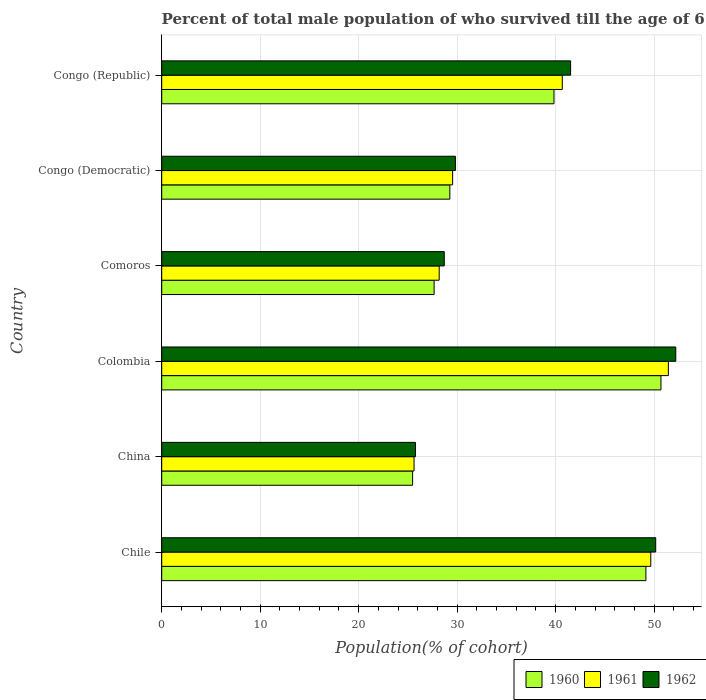How many different coloured bars are there?
Make the answer very short. 3. Are the number of bars per tick equal to the number of legend labels?
Your answer should be compact. Yes. Are the number of bars on each tick of the Y-axis equal?
Ensure brevity in your answer.  Yes. How many bars are there on the 6th tick from the top?
Your answer should be very brief. 3. What is the label of the 3rd group of bars from the top?
Your answer should be very brief. Comoros. In how many cases, is the number of bars for a given country not equal to the number of legend labels?
Offer a terse response. 0. What is the percentage of total male population who survived till the age of 65 years in 1962 in Chile?
Keep it short and to the point. 50.16. Across all countries, what is the maximum percentage of total male population who survived till the age of 65 years in 1962?
Provide a short and direct response. 52.2. Across all countries, what is the minimum percentage of total male population who survived till the age of 65 years in 1960?
Keep it short and to the point. 25.48. In which country was the percentage of total male population who survived till the age of 65 years in 1960 minimum?
Provide a succinct answer. China. What is the total percentage of total male population who survived till the age of 65 years in 1961 in the graph?
Your response must be concise. 225.14. What is the difference between the percentage of total male population who survived till the age of 65 years in 1962 in Colombia and that in Comoros?
Offer a terse response. 23.51. What is the difference between the percentage of total male population who survived till the age of 65 years in 1960 in Chile and the percentage of total male population who survived till the age of 65 years in 1961 in Congo (Democratic)?
Your answer should be compact. 19.63. What is the average percentage of total male population who survived till the age of 65 years in 1961 per country?
Your answer should be compact. 37.52. What is the difference between the percentage of total male population who survived till the age of 65 years in 1962 and percentage of total male population who survived till the age of 65 years in 1960 in Congo (Democratic)?
Ensure brevity in your answer.  0.57. What is the ratio of the percentage of total male population who survived till the age of 65 years in 1962 in Comoros to that in Congo (Democratic)?
Your answer should be very brief. 0.96. Is the percentage of total male population who survived till the age of 65 years in 1960 in Chile less than that in Comoros?
Provide a succinct answer. No. Is the difference between the percentage of total male population who survived till the age of 65 years in 1962 in Chile and Comoros greater than the difference between the percentage of total male population who survived till the age of 65 years in 1960 in Chile and Comoros?
Your answer should be compact. No. What is the difference between the highest and the second highest percentage of total male population who survived till the age of 65 years in 1960?
Provide a short and direct response. 1.53. What is the difference between the highest and the lowest percentage of total male population who survived till the age of 65 years in 1962?
Provide a succinct answer. 26.44. Is the sum of the percentage of total male population who survived till the age of 65 years in 1962 in Congo (Democratic) and Congo (Republic) greater than the maximum percentage of total male population who survived till the age of 65 years in 1961 across all countries?
Make the answer very short. Yes. What does the 1st bar from the top in Comoros represents?
Offer a terse response. 1962. What does the 2nd bar from the bottom in Chile represents?
Give a very brief answer. 1961. Are all the bars in the graph horizontal?
Your response must be concise. Yes. What is the difference between two consecutive major ticks on the X-axis?
Make the answer very short. 10. Are the values on the major ticks of X-axis written in scientific E-notation?
Your answer should be very brief. No. Does the graph contain any zero values?
Your answer should be compact. No. Does the graph contain grids?
Offer a very short reply. Yes. What is the title of the graph?
Your answer should be compact. Percent of total male population of who survived till the age of 65 years. What is the label or title of the X-axis?
Your answer should be compact. Population(% of cohort). What is the Population(% of cohort) in 1960 in Chile?
Ensure brevity in your answer.  49.17. What is the Population(% of cohort) of 1961 in Chile?
Make the answer very short. 49.67. What is the Population(% of cohort) in 1962 in Chile?
Provide a short and direct response. 50.16. What is the Population(% of cohort) of 1960 in China?
Offer a very short reply. 25.48. What is the Population(% of cohort) in 1961 in China?
Your answer should be compact. 25.62. What is the Population(% of cohort) in 1962 in China?
Your answer should be compact. 25.77. What is the Population(% of cohort) in 1960 in Colombia?
Provide a short and direct response. 50.7. What is the Population(% of cohort) of 1961 in Colombia?
Offer a terse response. 51.45. What is the Population(% of cohort) in 1962 in Colombia?
Provide a short and direct response. 52.2. What is the Population(% of cohort) of 1960 in Comoros?
Give a very brief answer. 27.66. What is the Population(% of cohort) of 1961 in Comoros?
Ensure brevity in your answer.  28.18. What is the Population(% of cohort) of 1962 in Comoros?
Your answer should be compact. 28.69. What is the Population(% of cohort) of 1960 in Congo (Democratic)?
Make the answer very short. 29.26. What is the Population(% of cohort) of 1961 in Congo (Democratic)?
Provide a succinct answer. 29.54. What is the Population(% of cohort) of 1962 in Congo (Democratic)?
Make the answer very short. 29.82. What is the Population(% of cohort) in 1960 in Congo (Republic)?
Make the answer very short. 39.84. What is the Population(% of cohort) of 1961 in Congo (Republic)?
Offer a terse response. 40.68. What is the Population(% of cohort) in 1962 in Congo (Republic)?
Keep it short and to the point. 41.52. Across all countries, what is the maximum Population(% of cohort) in 1960?
Your answer should be very brief. 50.7. Across all countries, what is the maximum Population(% of cohort) in 1961?
Your answer should be compact. 51.45. Across all countries, what is the maximum Population(% of cohort) in 1962?
Offer a terse response. 52.2. Across all countries, what is the minimum Population(% of cohort) in 1960?
Offer a very short reply. 25.48. Across all countries, what is the minimum Population(% of cohort) of 1961?
Offer a terse response. 25.62. Across all countries, what is the minimum Population(% of cohort) in 1962?
Offer a terse response. 25.77. What is the total Population(% of cohort) of 1960 in the graph?
Ensure brevity in your answer.  222.1. What is the total Population(% of cohort) of 1961 in the graph?
Your answer should be very brief. 225.14. What is the total Population(% of cohort) of 1962 in the graph?
Your response must be concise. 228.18. What is the difference between the Population(% of cohort) in 1960 in Chile and that in China?
Give a very brief answer. 23.69. What is the difference between the Population(% of cohort) of 1961 in Chile and that in China?
Your answer should be very brief. 24.04. What is the difference between the Population(% of cohort) of 1962 in Chile and that in China?
Ensure brevity in your answer.  24.4. What is the difference between the Population(% of cohort) in 1960 in Chile and that in Colombia?
Keep it short and to the point. -1.53. What is the difference between the Population(% of cohort) of 1961 in Chile and that in Colombia?
Your response must be concise. -1.78. What is the difference between the Population(% of cohort) in 1962 in Chile and that in Colombia?
Offer a terse response. -2.04. What is the difference between the Population(% of cohort) in 1960 in Chile and that in Comoros?
Your answer should be compact. 21.51. What is the difference between the Population(% of cohort) in 1961 in Chile and that in Comoros?
Your answer should be very brief. 21.49. What is the difference between the Population(% of cohort) in 1962 in Chile and that in Comoros?
Offer a terse response. 21.47. What is the difference between the Population(% of cohort) of 1960 in Chile and that in Congo (Democratic)?
Your response must be concise. 19.91. What is the difference between the Population(% of cohort) of 1961 in Chile and that in Congo (Democratic)?
Give a very brief answer. 20.12. What is the difference between the Population(% of cohort) in 1962 in Chile and that in Congo (Democratic)?
Your response must be concise. 20.34. What is the difference between the Population(% of cohort) in 1960 in Chile and that in Congo (Republic)?
Your response must be concise. 9.33. What is the difference between the Population(% of cohort) of 1961 in Chile and that in Congo (Republic)?
Your response must be concise. 8.99. What is the difference between the Population(% of cohort) in 1962 in Chile and that in Congo (Republic)?
Ensure brevity in your answer.  8.64. What is the difference between the Population(% of cohort) of 1960 in China and that in Colombia?
Provide a short and direct response. -25.22. What is the difference between the Population(% of cohort) in 1961 in China and that in Colombia?
Provide a succinct answer. -25.83. What is the difference between the Population(% of cohort) of 1962 in China and that in Colombia?
Keep it short and to the point. -26.44. What is the difference between the Population(% of cohort) of 1960 in China and that in Comoros?
Provide a short and direct response. -2.18. What is the difference between the Population(% of cohort) in 1961 in China and that in Comoros?
Offer a terse response. -2.55. What is the difference between the Population(% of cohort) in 1962 in China and that in Comoros?
Offer a very short reply. -2.93. What is the difference between the Population(% of cohort) in 1960 in China and that in Congo (Democratic)?
Ensure brevity in your answer.  -3.78. What is the difference between the Population(% of cohort) in 1961 in China and that in Congo (Democratic)?
Offer a terse response. -3.92. What is the difference between the Population(% of cohort) in 1962 in China and that in Congo (Democratic)?
Offer a very short reply. -4.06. What is the difference between the Population(% of cohort) of 1960 in China and that in Congo (Republic)?
Provide a succinct answer. -14.36. What is the difference between the Population(% of cohort) of 1961 in China and that in Congo (Republic)?
Give a very brief answer. -15.05. What is the difference between the Population(% of cohort) of 1962 in China and that in Congo (Republic)?
Provide a succinct answer. -15.75. What is the difference between the Population(% of cohort) in 1960 in Colombia and that in Comoros?
Provide a short and direct response. 23.03. What is the difference between the Population(% of cohort) of 1961 in Colombia and that in Comoros?
Your answer should be compact. 23.27. What is the difference between the Population(% of cohort) of 1962 in Colombia and that in Comoros?
Offer a very short reply. 23.51. What is the difference between the Population(% of cohort) in 1960 in Colombia and that in Congo (Democratic)?
Your answer should be compact. 21.44. What is the difference between the Population(% of cohort) of 1961 in Colombia and that in Congo (Democratic)?
Offer a very short reply. 21.91. What is the difference between the Population(% of cohort) in 1962 in Colombia and that in Congo (Democratic)?
Provide a succinct answer. 22.38. What is the difference between the Population(% of cohort) of 1960 in Colombia and that in Congo (Republic)?
Your response must be concise. 10.86. What is the difference between the Population(% of cohort) in 1961 in Colombia and that in Congo (Republic)?
Make the answer very short. 10.77. What is the difference between the Population(% of cohort) of 1962 in Colombia and that in Congo (Republic)?
Offer a terse response. 10.68. What is the difference between the Population(% of cohort) in 1960 in Comoros and that in Congo (Democratic)?
Provide a short and direct response. -1.6. What is the difference between the Population(% of cohort) of 1961 in Comoros and that in Congo (Democratic)?
Your answer should be very brief. -1.36. What is the difference between the Population(% of cohort) of 1962 in Comoros and that in Congo (Democratic)?
Your answer should be compact. -1.13. What is the difference between the Population(% of cohort) of 1960 in Comoros and that in Congo (Republic)?
Provide a succinct answer. -12.17. What is the difference between the Population(% of cohort) in 1961 in Comoros and that in Congo (Republic)?
Offer a very short reply. -12.5. What is the difference between the Population(% of cohort) of 1962 in Comoros and that in Congo (Republic)?
Your answer should be very brief. -12.83. What is the difference between the Population(% of cohort) in 1960 in Congo (Democratic) and that in Congo (Republic)?
Your answer should be very brief. -10.58. What is the difference between the Population(% of cohort) in 1961 in Congo (Democratic) and that in Congo (Republic)?
Ensure brevity in your answer.  -11.14. What is the difference between the Population(% of cohort) in 1962 in Congo (Democratic) and that in Congo (Republic)?
Ensure brevity in your answer.  -11.7. What is the difference between the Population(% of cohort) of 1960 in Chile and the Population(% of cohort) of 1961 in China?
Give a very brief answer. 23.55. What is the difference between the Population(% of cohort) in 1960 in Chile and the Population(% of cohort) in 1962 in China?
Offer a terse response. 23.4. What is the difference between the Population(% of cohort) in 1961 in Chile and the Population(% of cohort) in 1962 in China?
Provide a succinct answer. 23.9. What is the difference between the Population(% of cohort) in 1960 in Chile and the Population(% of cohort) in 1961 in Colombia?
Your answer should be very brief. -2.28. What is the difference between the Population(% of cohort) in 1960 in Chile and the Population(% of cohort) in 1962 in Colombia?
Offer a very short reply. -3.03. What is the difference between the Population(% of cohort) of 1961 in Chile and the Population(% of cohort) of 1962 in Colombia?
Offer a very short reply. -2.54. What is the difference between the Population(% of cohort) of 1960 in Chile and the Population(% of cohort) of 1961 in Comoros?
Your answer should be compact. 20.99. What is the difference between the Population(% of cohort) in 1960 in Chile and the Population(% of cohort) in 1962 in Comoros?
Give a very brief answer. 20.48. What is the difference between the Population(% of cohort) of 1961 in Chile and the Population(% of cohort) of 1962 in Comoros?
Provide a short and direct response. 20.97. What is the difference between the Population(% of cohort) of 1960 in Chile and the Population(% of cohort) of 1961 in Congo (Democratic)?
Your answer should be compact. 19.63. What is the difference between the Population(% of cohort) in 1960 in Chile and the Population(% of cohort) in 1962 in Congo (Democratic)?
Provide a succinct answer. 19.34. What is the difference between the Population(% of cohort) of 1961 in Chile and the Population(% of cohort) of 1962 in Congo (Democratic)?
Provide a succinct answer. 19.84. What is the difference between the Population(% of cohort) in 1960 in Chile and the Population(% of cohort) in 1961 in Congo (Republic)?
Ensure brevity in your answer.  8.49. What is the difference between the Population(% of cohort) in 1960 in Chile and the Population(% of cohort) in 1962 in Congo (Republic)?
Keep it short and to the point. 7.65. What is the difference between the Population(% of cohort) of 1961 in Chile and the Population(% of cohort) of 1962 in Congo (Republic)?
Make the answer very short. 8.15. What is the difference between the Population(% of cohort) of 1960 in China and the Population(% of cohort) of 1961 in Colombia?
Give a very brief answer. -25.97. What is the difference between the Population(% of cohort) of 1960 in China and the Population(% of cohort) of 1962 in Colombia?
Ensure brevity in your answer.  -26.72. What is the difference between the Population(% of cohort) of 1961 in China and the Population(% of cohort) of 1962 in Colombia?
Keep it short and to the point. -26.58. What is the difference between the Population(% of cohort) of 1960 in China and the Population(% of cohort) of 1961 in Comoros?
Provide a succinct answer. -2.7. What is the difference between the Population(% of cohort) in 1960 in China and the Population(% of cohort) in 1962 in Comoros?
Your answer should be very brief. -3.21. What is the difference between the Population(% of cohort) in 1961 in China and the Population(% of cohort) in 1962 in Comoros?
Give a very brief answer. -3.07. What is the difference between the Population(% of cohort) of 1960 in China and the Population(% of cohort) of 1961 in Congo (Democratic)?
Give a very brief answer. -4.06. What is the difference between the Population(% of cohort) of 1960 in China and the Population(% of cohort) of 1962 in Congo (Democratic)?
Keep it short and to the point. -4.35. What is the difference between the Population(% of cohort) in 1961 in China and the Population(% of cohort) in 1962 in Congo (Democratic)?
Your answer should be very brief. -4.2. What is the difference between the Population(% of cohort) of 1960 in China and the Population(% of cohort) of 1961 in Congo (Republic)?
Give a very brief answer. -15.2. What is the difference between the Population(% of cohort) in 1960 in China and the Population(% of cohort) in 1962 in Congo (Republic)?
Provide a succinct answer. -16.04. What is the difference between the Population(% of cohort) of 1961 in China and the Population(% of cohort) of 1962 in Congo (Republic)?
Offer a terse response. -15.9. What is the difference between the Population(% of cohort) in 1960 in Colombia and the Population(% of cohort) in 1961 in Comoros?
Make the answer very short. 22.52. What is the difference between the Population(% of cohort) in 1960 in Colombia and the Population(% of cohort) in 1962 in Comoros?
Ensure brevity in your answer.  22. What is the difference between the Population(% of cohort) of 1961 in Colombia and the Population(% of cohort) of 1962 in Comoros?
Your answer should be very brief. 22.76. What is the difference between the Population(% of cohort) of 1960 in Colombia and the Population(% of cohort) of 1961 in Congo (Democratic)?
Ensure brevity in your answer.  21.16. What is the difference between the Population(% of cohort) in 1960 in Colombia and the Population(% of cohort) in 1962 in Congo (Democratic)?
Provide a succinct answer. 20.87. What is the difference between the Population(% of cohort) in 1961 in Colombia and the Population(% of cohort) in 1962 in Congo (Democratic)?
Keep it short and to the point. 21.63. What is the difference between the Population(% of cohort) in 1960 in Colombia and the Population(% of cohort) in 1961 in Congo (Republic)?
Make the answer very short. 10.02. What is the difference between the Population(% of cohort) in 1960 in Colombia and the Population(% of cohort) in 1962 in Congo (Republic)?
Your answer should be compact. 9.18. What is the difference between the Population(% of cohort) in 1961 in Colombia and the Population(% of cohort) in 1962 in Congo (Republic)?
Your response must be concise. 9.93. What is the difference between the Population(% of cohort) in 1960 in Comoros and the Population(% of cohort) in 1961 in Congo (Democratic)?
Offer a very short reply. -1.88. What is the difference between the Population(% of cohort) in 1960 in Comoros and the Population(% of cohort) in 1962 in Congo (Democratic)?
Your answer should be very brief. -2.16. What is the difference between the Population(% of cohort) of 1961 in Comoros and the Population(% of cohort) of 1962 in Congo (Democratic)?
Your response must be concise. -1.65. What is the difference between the Population(% of cohort) of 1960 in Comoros and the Population(% of cohort) of 1961 in Congo (Republic)?
Provide a succinct answer. -13.02. What is the difference between the Population(% of cohort) in 1960 in Comoros and the Population(% of cohort) in 1962 in Congo (Republic)?
Give a very brief answer. -13.86. What is the difference between the Population(% of cohort) of 1961 in Comoros and the Population(% of cohort) of 1962 in Congo (Republic)?
Give a very brief answer. -13.34. What is the difference between the Population(% of cohort) of 1960 in Congo (Democratic) and the Population(% of cohort) of 1961 in Congo (Republic)?
Offer a terse response. -11.42. What is the difference between the Population(% of cohort) in 1960 in Congo (Democratic) and the Population(% of cohort) in 1962 in Congo (Republic)?
Keep it short and to the point. -12.26. What is the difference between the Population(% of cohort) of 1961 in Congo (Democratic) and the Population(% of cohort) of 1962 in Congo (Republic)?
Your response must be concise. -11.98. What is the average Population(% of cohort) in 1960 per country?
Give a very brief answer. 37.02. What is the average Population(% of cohort) of 1961 per country?
Your response must be concise. 37.52. What is the average Population(% of cohort) in 1962 per country?
Your answer should be very brief. 38.03. What is the difference between the Population(% of cohort) in 1960 and Population(% of cohort) in 1961 in Chile?
Your response must be concise. -0.5. What is the difference between the Population(% of cohort) in 1960 and Population(% of cohort) in 1962 in Chile?
Provide a short and direct response. -1. What is the difference between the Population(% of cohort) in 1961 and Population(% of cohort) in 1962 in Chile?
Offer a terse response. -0.5. What is the difference between the Population(% of cohort) of 1960 and Population(% of cohort) of 1961 in China?
Keep it short and to the point. -0.14. What is the difference between the Population(% of cohort) of 1960 and Population(% of cohort) of 1962 in China?
Your answer should be very brief. -0.29. What is the difference between the Population(% of cohort) of 1961 and Population(% of cohort) of 1962 in China?
Provide a succinct answer. -0.14. What is the difference between the Population(% of cohort) in 1960 and Population(% of cohort) in 1961 in Colombia?
Offer a very short reply. -0.75. What is the difference between the Population(% of cohort) of 1960 and Population(% of cohort) of 1962 in Colombia?
Offer a terse response. -1.51. What is the difference between the Population(% of cohort) of 1961 and Population(% of cohort) of 1962 in Colombia?
Provide a succinct answer. -0.75. What is the difference between the Population(% of cohort) in 1960 and Population(% of cohort) in 1961 in Comoros?
Your response must be concise. -0.52. What is the difference between the Population(% of cohort) in 1960 and Population(% of cohort) in 1962 in Comoros?
Your answer should be compact. -1.03. What is the difference between the Population(% of cohort) of 1961 and Population(% of cohort) of 1962 in Comoros?
Your response must be concise. -0.52. What is the difference between the Population(% of cohort) in 1960 and Population(% of cohort) in 1961 in Congo (Democratic)?
Keep it short and to the point. -0.28. What is the difference between the Population(% of cohort) in 1960 and Population(% of cohort) in 1962 in Congo (Democratic)?
Offer a very short reply. -0.57. What is the difference between the Population(% of cohort) of 1961 and Population(% of cohort) of 1962 in Congo (Democratic)?
Offer a very short reply. -0.28. What is the difference between the Population(% of cohort) in 1960 and Population(% of cohort) in 1961 in Congo (Republic)?
Offer a very short reply. -0.84. What is the difference between the Population(% of cohort) of 1960 and Population(% of cohort) of 1962 in Congo (Republic)?
Provide a short and direct response. -1.69. What is the difference between the Population(% of cohort) in 1961 and Population(% of cohort) in 1962 in Congo (Republic)?
Make the answer very short. -0.84. What is the ratio of the Population(% of cohort) of 1960 in Chile to that in China?
Make the answer very short. 1.93. What is the ratio of the Population(% of cohort) in 1961 in Chile to that in China?
Your answer should be compact. 1.94. What is the ratio of the Population(% of cohort) in 1962 in Chile to that in China?
Provide a succinct answer. 1.95. What is the ratio of the Population(% of cohort) of 1960 in Chile to that in Colombia?
Provide a succinct answer. 0.97. What is the ratio of the Population(% of cohort) in 1961 in Chile to that in Colombia?
Ensure brevity in your answer.  0.97. What is the ratio of the Population(% of cohort) in 1962 in Chile to that in Colombia?
Provide a succinct answer. 0.96. What is the ratio of the Population(% of cohort) in 1960 in Chile to that in Comoros?
Offer a very short reply. 1.78. What is the ratio of the Population(% of cohort) in 1961 in Chile to that in Comoros?
Provide a succinct answer. 1.76. What is the ratio of the Population(% of cohort) in 1962 in Chile to that in Comoros?
Offer a terse response. 1.75. What is the ratio of the Population(% of cohort) of 1960 in Chile to that in Congo (Democratic)?
Your response must be concise. 1.68. What is the ratio of the Population(% of cohort) of 1961 in Chile to that in Congo (Democratic)?
Keep it short and to the point. 1.68. What is the ratio of the Population(% of cohort) in 1962 in Chile to that in Congo (Democratic)?
Offer a very short reply. 1.68. What is the ratio of the Population(% of cohort) of 1960 in Chile to that in Congo (Republic)?
Your answer should be very brief. 1.23. What is the ratio of the Population(% of cohort) in 1961 in Chile to that in Congo (Republic)?
Make the answer very short. 1.22. What is the ratio of the Population(% of cohort) in 1962 in Chile to that in Congo (Republic)?
Your answer should be compact. 1.21. What is the ratio of the Population(% of cohort) of 1960 in China to that in Colombia?
Your answer should be very brief. 0.5. What is the ratio of the Population(% of cohort) in 1961 in China to that in Colombia?
Offer a terse response. 0.5. What is the ratio of the Population(% of cohort) in 1962 in China to that in Colombia?
Ensure brevity in your answer.  0.49. What is the ratio of the Population(% of cohort) of 1960 in China to that in Comoros?
Keep it short and to the point. 0.92. What is the ratio of the Population(% of cohort) in 1961 in China to that in Comoros?
Provide a succinct answer. 0.91. What is the ratio of the Population(% of cohort) of 1962 in China to that in Comoros?
Offer a very short reply. 0.9. What is the ratio of the Population(% of cohort) of 1960 in China to that in Congo (Democratic)?
Your answer should be very brief. 0.87. What is the ratio of the Population(% of cohort) in 1961 in China to that in Congo (Democratic)?
Provide a short and direct response. 0.87. What is the ratio of the Population(% of cohort) of 1962 in China to that in Congo (Democratic)?
Your answer should be compact. 0.86. What is the ratio of the Population(% of cohort) of 1960 in China to that in Congo (Republic)?
Offer a very short reply. 0.64. What is the ratio of the Population(% of cohort) of 1961 in China to that in Congo (Republic)?
Your answer should be compact. 0.63. What is the ratio of the Population(% of cohort) in 1962 in China to that in Congo (Republic)?
Your answer should be compact. 0.62. What is the ratio of the Population(% of cohort) of 1960 in Colombia to that in Comoros?
Make the answer very short. 1.83. What is the ratio of the Population(% of cohort) in 1961 in Colombia to that in Comoros?
Provide a short and direct response. 1.83. What is the ratio of the Population(% of cohort) of 1962 in Colombia to that in Comoros?
Ensure brevity in your answer.  1.82. What is the ratio of the Population(% of cohort) of 1960 in Colombia to that in Congo (Democratic)?
Make the answer very short. 1.73. What is the ratio of the Population(% of cohort) in 1961 in Colombia to that in Congo (Democratic)?
Your response must be concise. 1.74. What is the ratio of the Population(% of cohort) in 1962 in Colombia to that in Congo (Democratic)?
Your response must be concise. 1.75. What is the ratio of the Population(% of cohort) in 1960 in Colombia to that in Congo (Republic)?
Give a very brief answer. 1.27. What is the ratio of the Population(% of cohort) in 1961 in Colombia to that in Congo (Republic)?
Make the answer very short. 1.26. What is the ratio of the Population(% of cohort) of 1962 in Colombia to that in Congo (Republic)?
Your answer should be compact. 1.26. What is the ratio of the Population(% of cohort) in 1960 in Comoros to that in Congo (Democratic)?
Provide a succinct answer. 0.95. What is the ratio of the Population(% of cohort) of 1961 in Comoros to that in Congo (Democratic)?
Your answer should be very brief. 0.95. What is the ratio of the Population(% of cohort) of 1962 in Comoros to that in Congo (Democratic)?
Your answer should be very brief. 0.96. What is the ratio of the Population(% of cohort) in 1960 in Comoros to that in Congo (Republic)?
Ensure brevity in your answer.  0.69. What is the ratio of the Population(% of cohort) in 1961 in Comoros to that in Congo (Republic)?
Keep it short and to the point. 0.69. What is the ratio of the Population(% of cohort) in 1962 in Comoros to that in Congo (Republic)?
Your response must be concise. 0.69. What is the ratio of the Population(% of cohort) of 1960 in Congo (Democratic) to that in Congo (Republic)?
Your response must be concise. 0.73. What is the ratio of the Population(% of cohort) in 1961 in Congo (Democratic) to that in Congo (Republic)?
Your answer should be very brief. 0.73. What is the ratio of the Population(% of cohort) of 1962 in Congo (Democratic) to that in Congo (Republic)?
Keep it short and to the point. 0.72. What is the difference between the highest and the second highest Population(% of cohort) in 1960?
Provide a short and direct response. 1.53. What is the difference between the highest and the second highest Population(% of cohort) of 1961?
Make the answer very short. 1.78. What is the difference between the highest and the second highest Population(% of cohort) of 1962?
Your answer should be very brief. 2.04. What is the difference between the highest and the lowest Population(% of cohort) of 1960?
Your response must be concise. 25.22. What is the difference between the highest and the lowest Population(% of cohort) of 1961?
Provide a short and direct response. 25.83. What is the difference between the highest and the lowest Population(% of cohort) of 1962?
Your answer should be very brief. 26.44. 